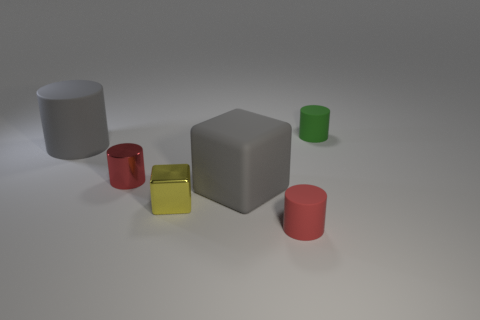Add 2 small objects. How many objects exist? 8 Subtract all blocks. How many objects are left? 4 Add 4 large gray spheres. How many large gray spheres exist? 4 Subtract 0 green spheres. How many objects are left? 6 Subtract all gray matte cylinders. Subtract all metallic cylinders. How many objects are left? 4 Add 1 matte things. How many matte things are left? 5 